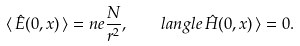<formula> <loc_0><loc_0><loc_500><loc_500>\langle \, \hat { E } ( 0 , { x } ) \, \rangle = n e \frac { N } { r ^ { 2 } } , \quad l a n g l e \, \hat { H } ( 0 , { x } ) \, \rangle = 0 .</formula> 